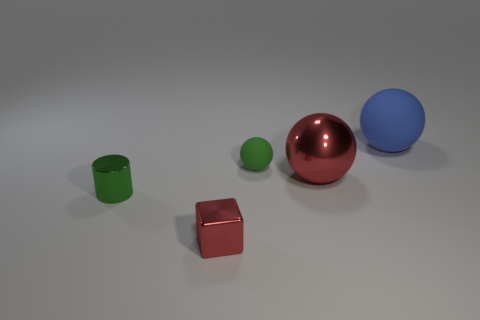Are any small green objects visible?
Provide a succinct answer. Yes. Is the number of big red shiny balls less than the number of blue rubber blocks?
Your answer should be very brief. No. How many small yellow spheres are made of the same material as the block?
Give a very brief answer. 0. What is the color of the other large sphere that is made of the same material as the green sphere?
Keep it short and to the point. Blue. What is the shape of the tiny red thing?
Your answer should be very brief. Cube. What number of tiny matte things are the same color as the big shiny thing?
Make the answer very short. 0. There is a green metallic object that is the same size as the red metal cube; what shape is it?
Your answer should be compact. Cylinder. Are there any blue rubber spheres of the same size as the red shiny ball?
Offer a terse response. Yes. What material is the block that is the same size as the green metallic object?
Make the answer very short. Metal. What is the size of the red object that is left of the tiny green thing that is behind the large red sphere?
Offer a very short reply. Small. 